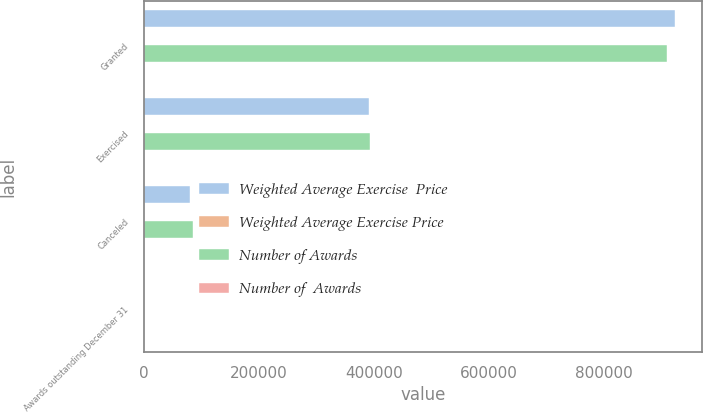<chart> <loc_0><loc_0><loc_500><loc_500><stacked_bar_chart><ecel><fcel>Granted<fcel>Exercised<fcel>Canceled<fcel>Awards outstanding December 31<nl><fcel>Weighted Average Exercise  Price<fcel>924000<fcel>390856<fcel>80564<fcel>45.315<nl><fcel>Weighted Average Exercise Price<fcel>38.72<fcel>28.59<fcel>45.51<fcel>40.3<nl><fcel>Number of Awards<fcel>910375<fcel>392519<fcel>85469<fcel>45.315<nl><fcel>Number of  Awards<fcel>43.84<fcel>24.67<fcel>45.12<fcel>39.91<nl></chart> 